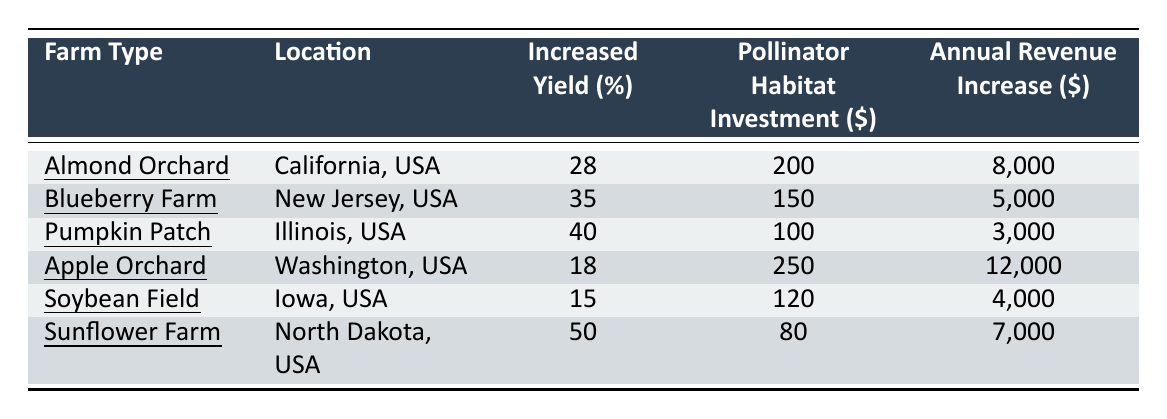What is the increased yield percentage for the Sunflower Farm? From the table, we can find the row corresponding to the Sunflower Farm and see that the Increased Yield Percentage is listed as 50%.
Answer: 50% Which farm had the highest annual revenue increase? By examining the Annual Revenue Increase column, we can see that the Apple Orchard has the highest value at $12,000.
Answer: Apple Orchard What is the total investment made in pollinator habitats across all farms? We add the Pollinator Habitat Investment amounts together: 200 + 150 + 100 + 250 + 120 + 80 = 1,000.
Answer: 1,000 Is the increased yield percentage for the Pumpkin Patch greater than that for the Soybean Field? The Increased Yield Percentage for the Pumpkin Patch is 40% and for the Soybean Field is 15%. Since 40% is greater than 15%, the statement is true.
Answer: Yes What is the average annual revenue increase of all the farms? First, we sum the Annual Revenue Increase amounts: 8000 + 5000 + 3000 + 12000 + 4000 + 7000 = 40000. There are 6 farms, so we divide 40000 by 6 to get an average of approximately 6666.67.
Answer: 6666.67 Which farm requires the least investment in pollinator habitats? Looking at the Pollinator Habitat Investment column, the Sunflower Farm requires only $80, which is the lowest among the listed farms.
Answer: Sunflower Farm How does the increased yield percentage of the Blueberry Farm compare to the Apple Orchard? The Blueberry Farm has an increased yield percentage of 35% and the Apple Orchard has 18%. Since 35% is greater than 18%, the Blueberry Farm has a higher percentage.
Answer: Blueberry Farm If we rank the farms by their increased yield percentages, which farm is in the middle position? We can order the farms by their increased yield percentages: (Sunflower Farm 50%, Pumpkin Patch 40%, Blueberry Farm 35%, Almond Orchard 28%, Apple Orchard 18%, Soybean Field 15%). In this order, the farm in the middle position (3rd out of 6) is the Blueberry Farm.
Answer: Blueberry Farm 